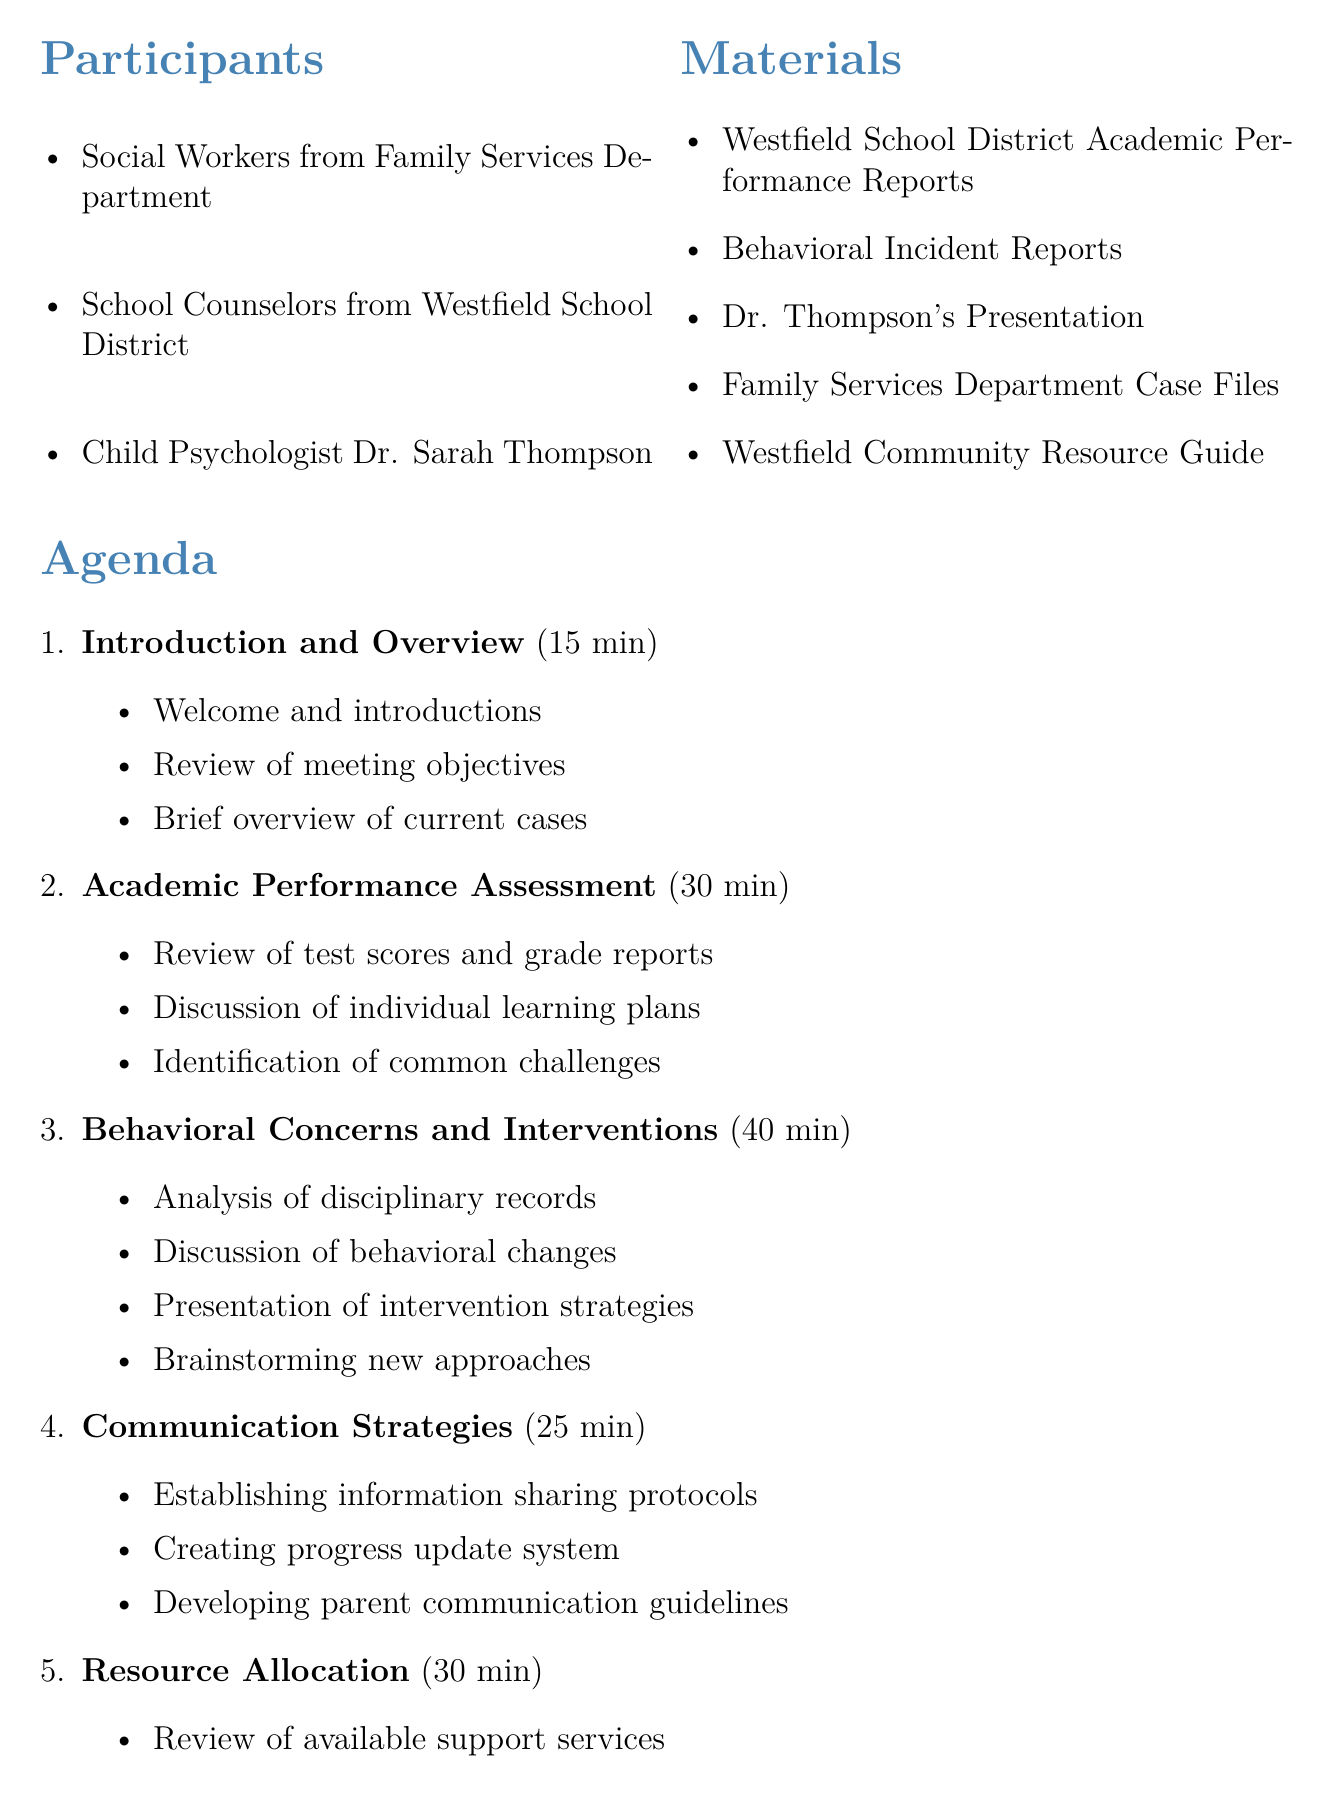What is the title of the meeting? The title of the meeting is listed at the beginning of the document.
Answer: Collaborative Meeting: Addressing Academic and Behavioral Concerns of Children in Custody Disputes Who is the child psychologist participating? The document lists the participants, including the child psychologist.
Answer: Dr. Sarah Thompson What is the duration of the Behavioral Concerns and Interventions topic? The duration of each agenda topic is specified in the document.
Answer: 40 minutes What is one of the materials listed for the meeting? The materials section contains the resources available for the meeting.
Answer: Westfield School District Academic Performance Reports How many participants are involved in the meeting? The document details the participants and their roles.
Answer: Three 